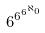<formula> <loc_0><loc_0><loc_500><loc_500>6 ^ { 6 ^ { 6 ^ { \aleph _ { 0 } } } }</formula> 